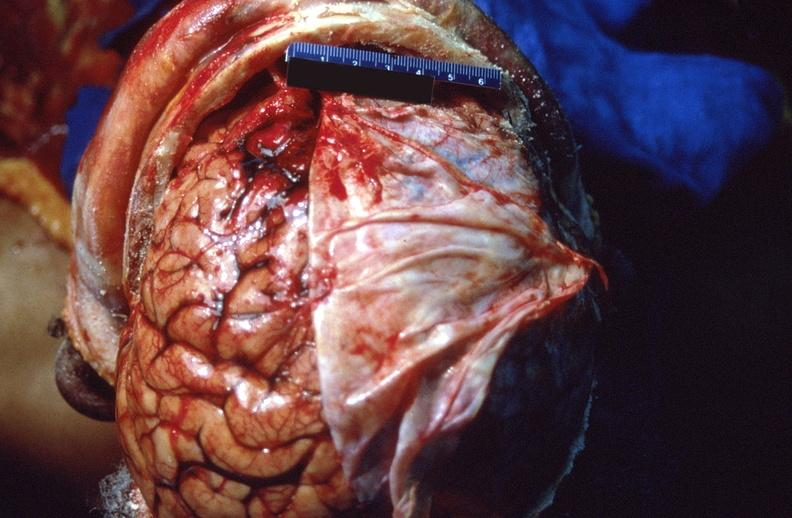s nervous present?
Answer the question using a single word or phrase. Yes 